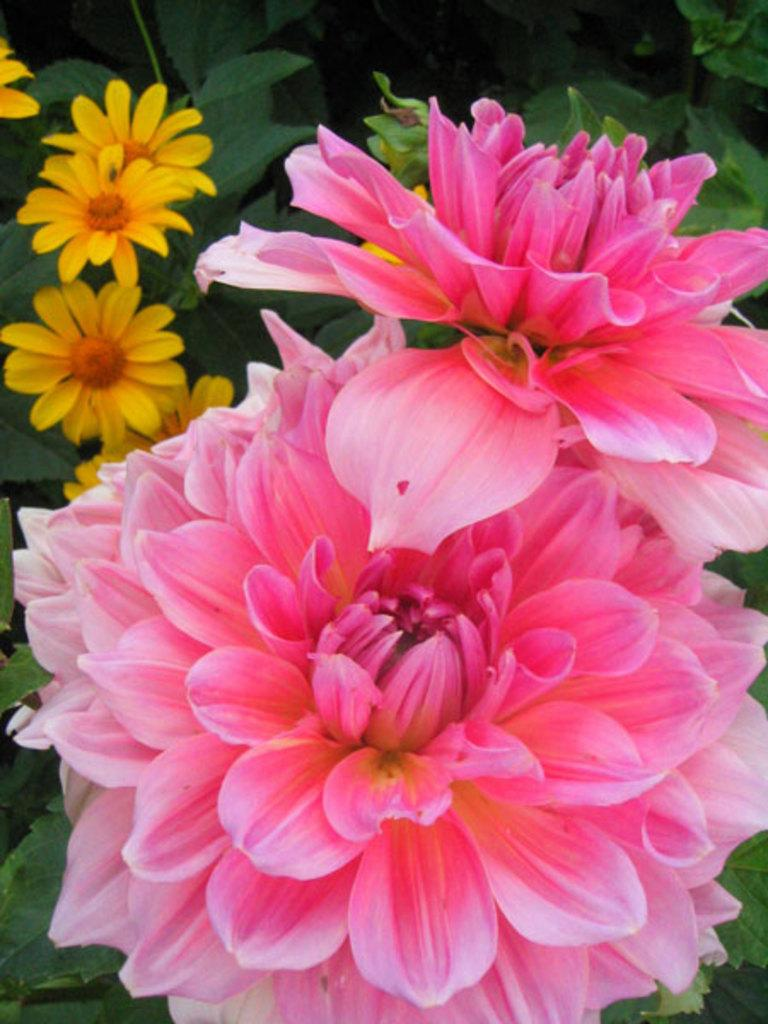What type of living organisms can be seen in the image? Flowers and plants are visible in the image. Can you describe the plants in the image? The image contains flowers, which are a type of plant. Are there any other plants visible in the image besides the flowers? Yes, there are other plants visible in the image. What is the expert's opinion on the aftermath of the blow in the image? There is no expert, blow, or aftermath present in the image, as it only contains flowers and plants. 